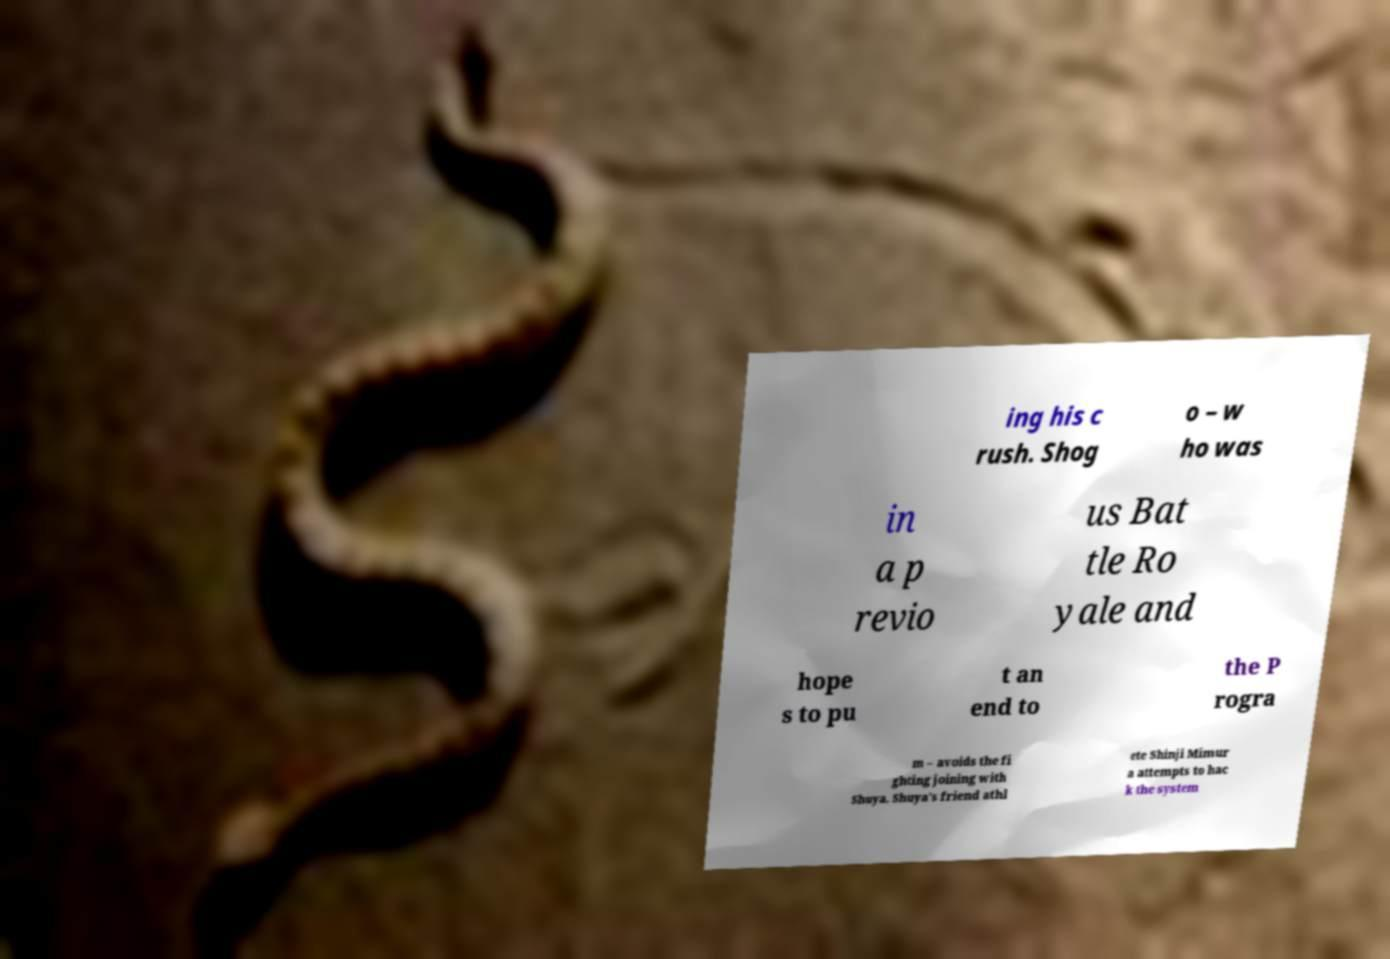Please identify and transcribe the text found in this image. ing his c rush. Shog o – w ho was in a p revio us Bat tle Ro yale and hope s to pu t an end to the P rogra m – avoids the fi ghting joining with Shuya. Shuya's friend athl ete Shinji Mimur a attempts to hac k the system 